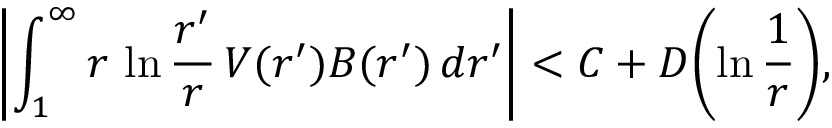<formula> <loc_0><loc_0><loc_500><loc_500>\left | \int _ { 1 } ^ { \infty } r \, \ln { \frac { r ^ { \prime } } { r } } \, V ( r ^ { \prime } ) B ( r ^ { \prime } ) \, d r ^ { \prime } \right | < C + D \left ( \ln { \frac { 1 } { r } } \right ) ,</formula> 